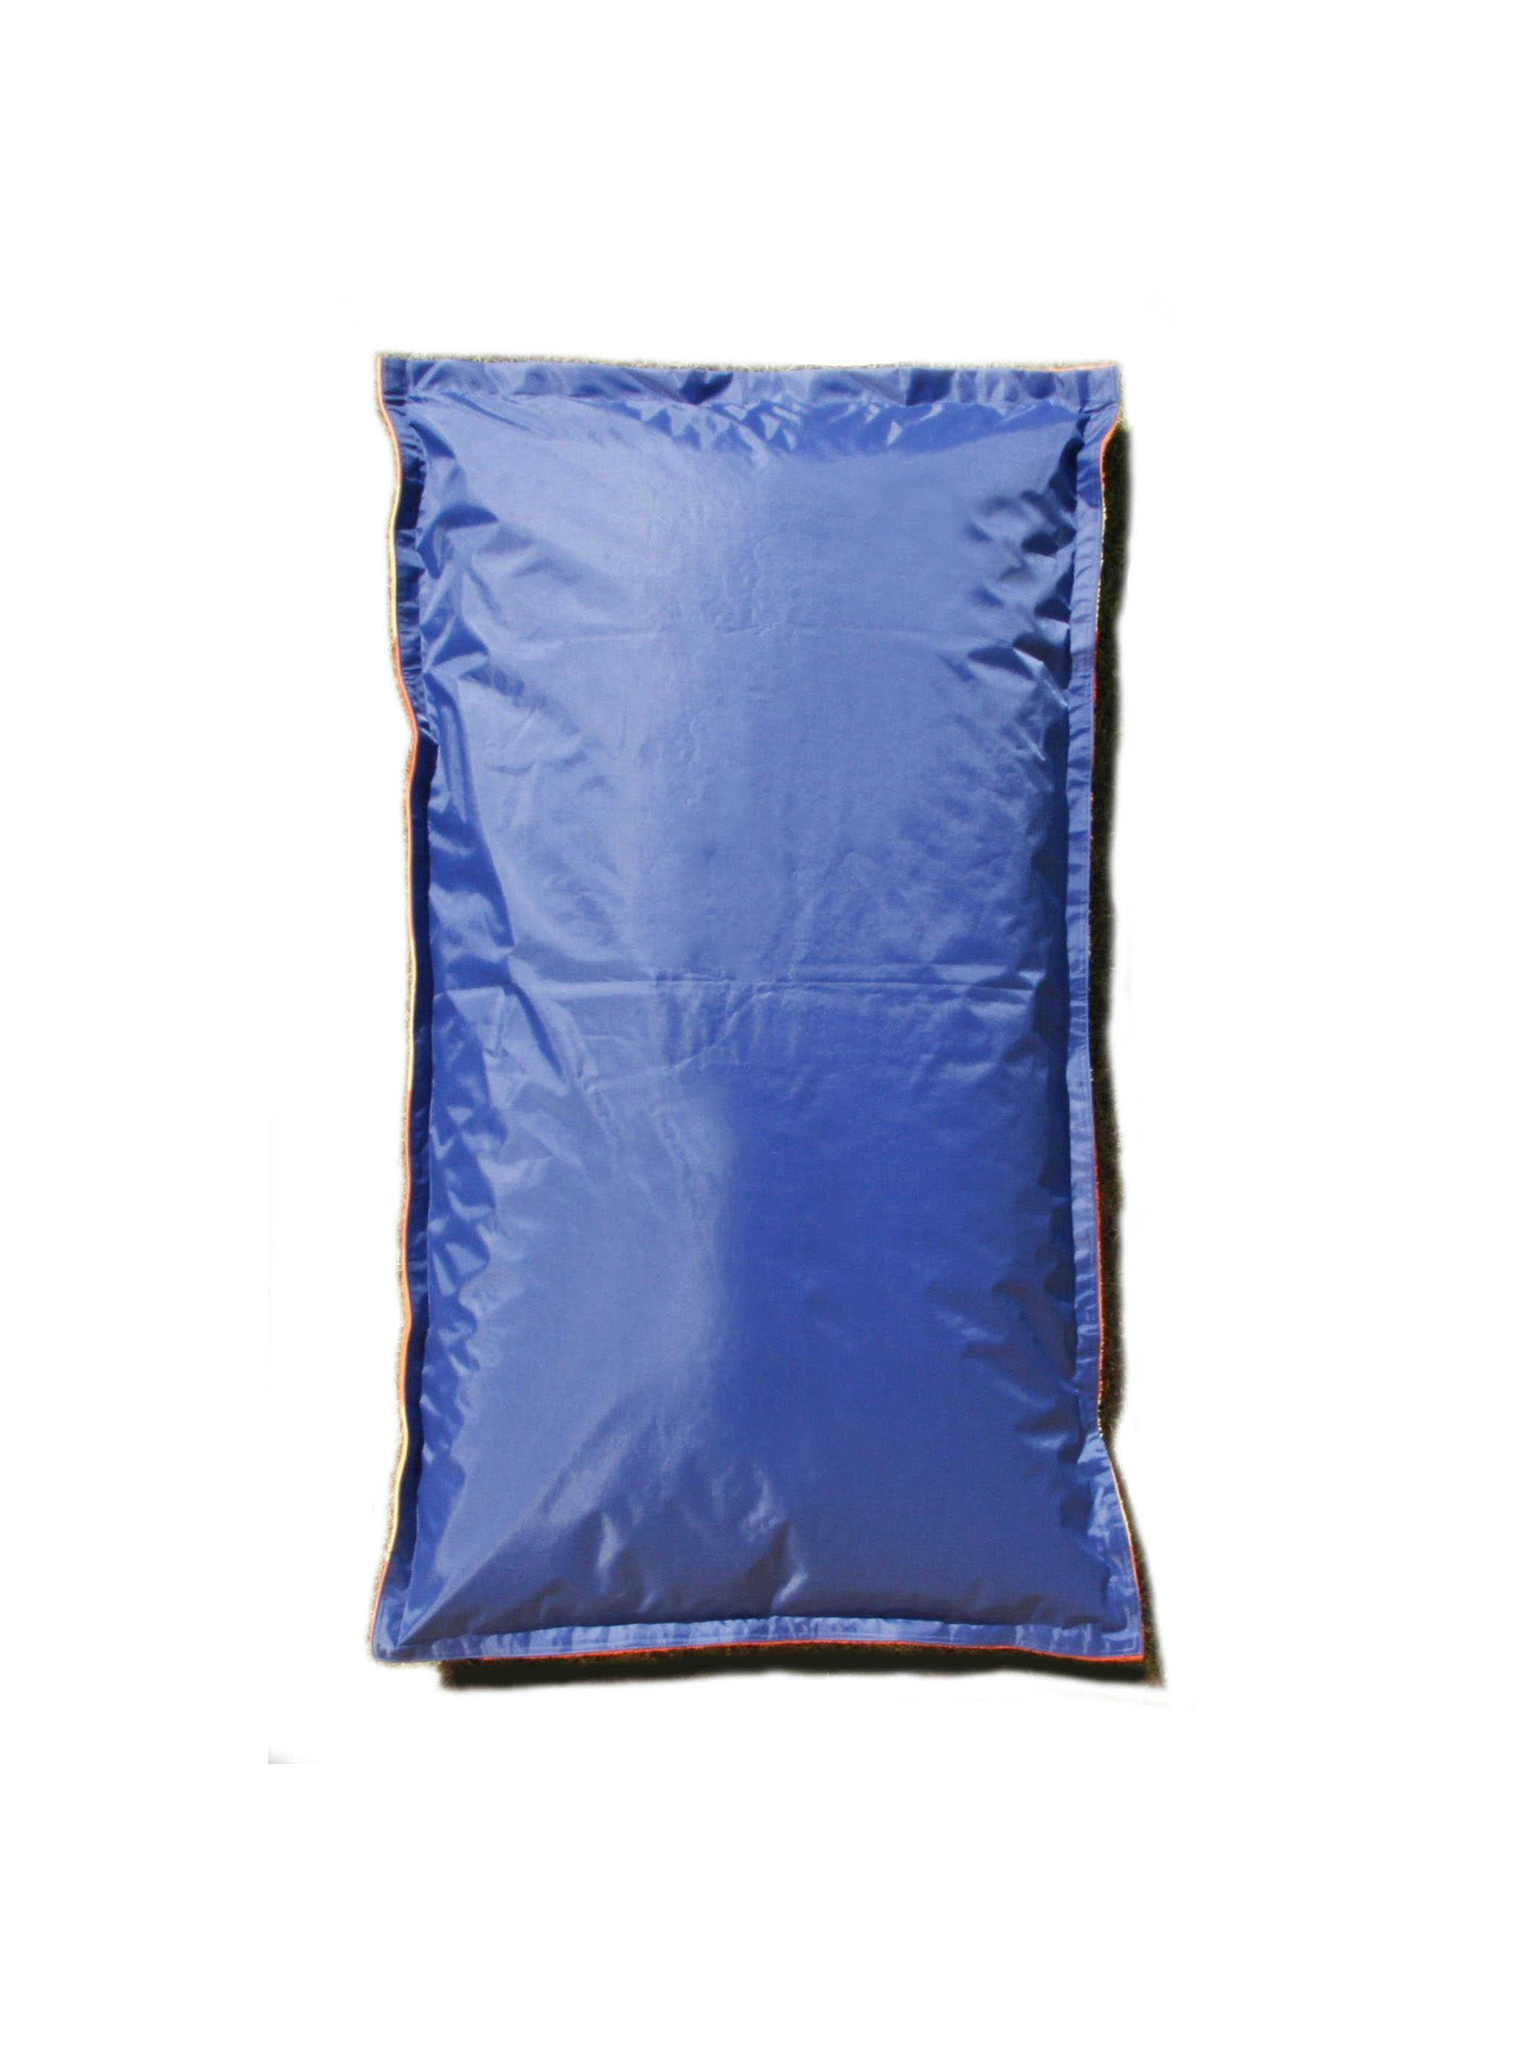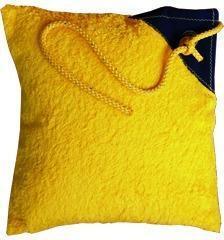The first image is the image on the left, the second image is the image on the right. Examine the images to the left and right. Is the description "The pillow is in front of a bench" accurate? Answer yes or no. No. The first image is the image on the left, the second image is the image on the right. Given the left and right images, does the statement "At least one of the cushions is knitted." hold true? Answer yes or no. No. 